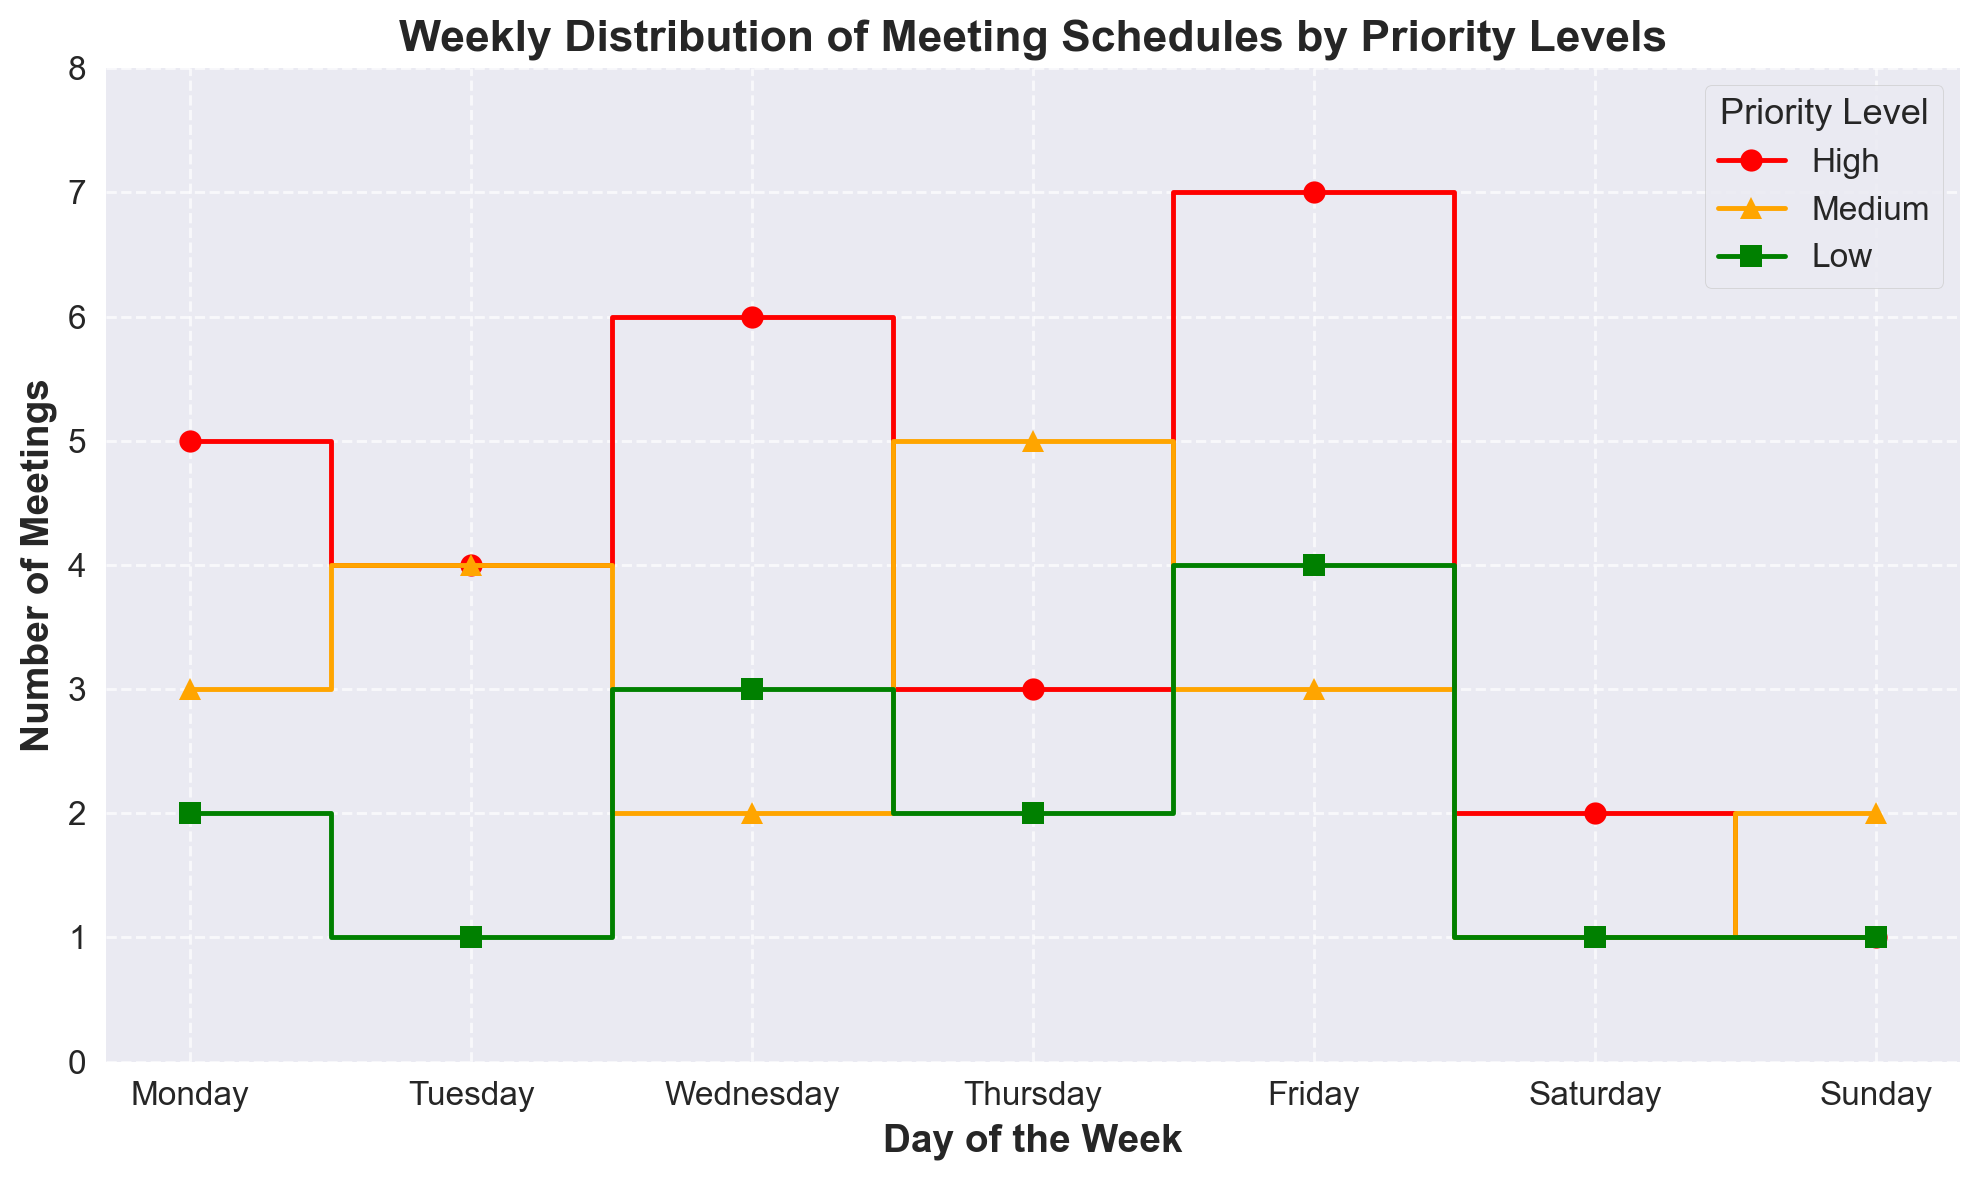What day has the highest number of high-priority meetings? To determine the day with the highest number of high-priority meetings, look at the red steps on the figure. The highest value is on Friday with 7 meetings.
Answer: Friday What is the total number of meetings on Wednesday? To find the total number of meetings on Wednesday, add the high (6), medium (2), and low (3) priority meetings: 6 + 2 + 3 = 11.
Answer: 11 How does the number of medium-priority meetings on Thursday compare to that on Monday? Look at the orange steps for medium-priority meetings for both days. Thursday has 5 medium-priority meetings while Monday has 3. Thursday has more medium-priority meetings.
Answer: Thursday Which day has the fewest low-priority meetings? For the lowest values in the green steps representing low-priority meetings, Saturday and Sunday both have the minimum of 1 low-priority meeting.
Answer: Saturday and Sunday How many more high-priority meetings are there on Friday than on Tuesday? To calculate, subtract the number of high-priority meetings on Tuesday (4) from Friday (7): 7 - 4 = 3.
Answer: 3 What is the average number of low-priority meetings per day? Calculate the total number of low-priority meetings over the week and then divide by the number of days. Total is 2 + 1 + 3 + 2 + 4 + 1 + 1 = 14. Average is 14 / 7 = 2.
Answer: 2 Are there more high-priority meetings on Wednesday or medium-priority meetings on Thursday? Check the red steps for Wednesday and the orange steps for Thursday. High-priority meetings on Wednesday are 6, while medium-priority meetings on Thursday are 5. Thus, Wednesday has more high-priority meetings.
Answer: Wednesday Which priority level consistently has the lowest number of meetings across the week? Observing all days, low-priority meetings (green) consistently have lower counts compared to high (red) and medium (orange) meetings.
Answer: Low Is the number of meetings with medium priority greater on Monday or Wednesday? Compare the orange steps on Monday (3 medium-priority meetings) to Wednesday (2 medium-priority meetings). Monday has more medium-priority meetings.
Answer: Monday 